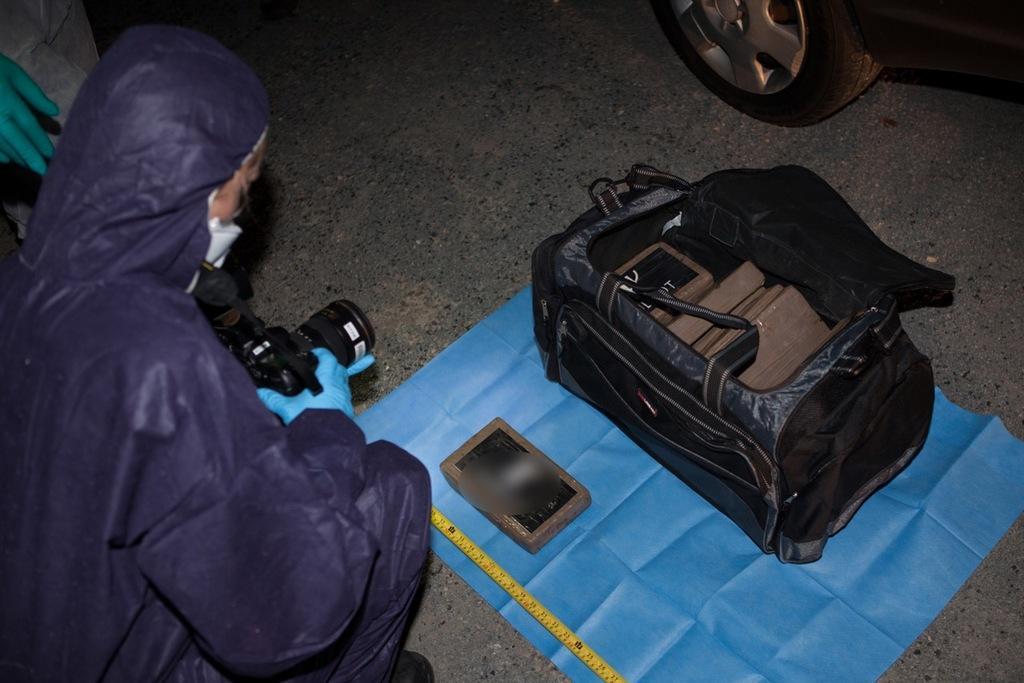Please provide a concise description of this image. In the image on the left we can see one person sitting and holding camera. In the center,we can see boxes,scale,bag and cloth. On the top right of the image there is a vehicle. 